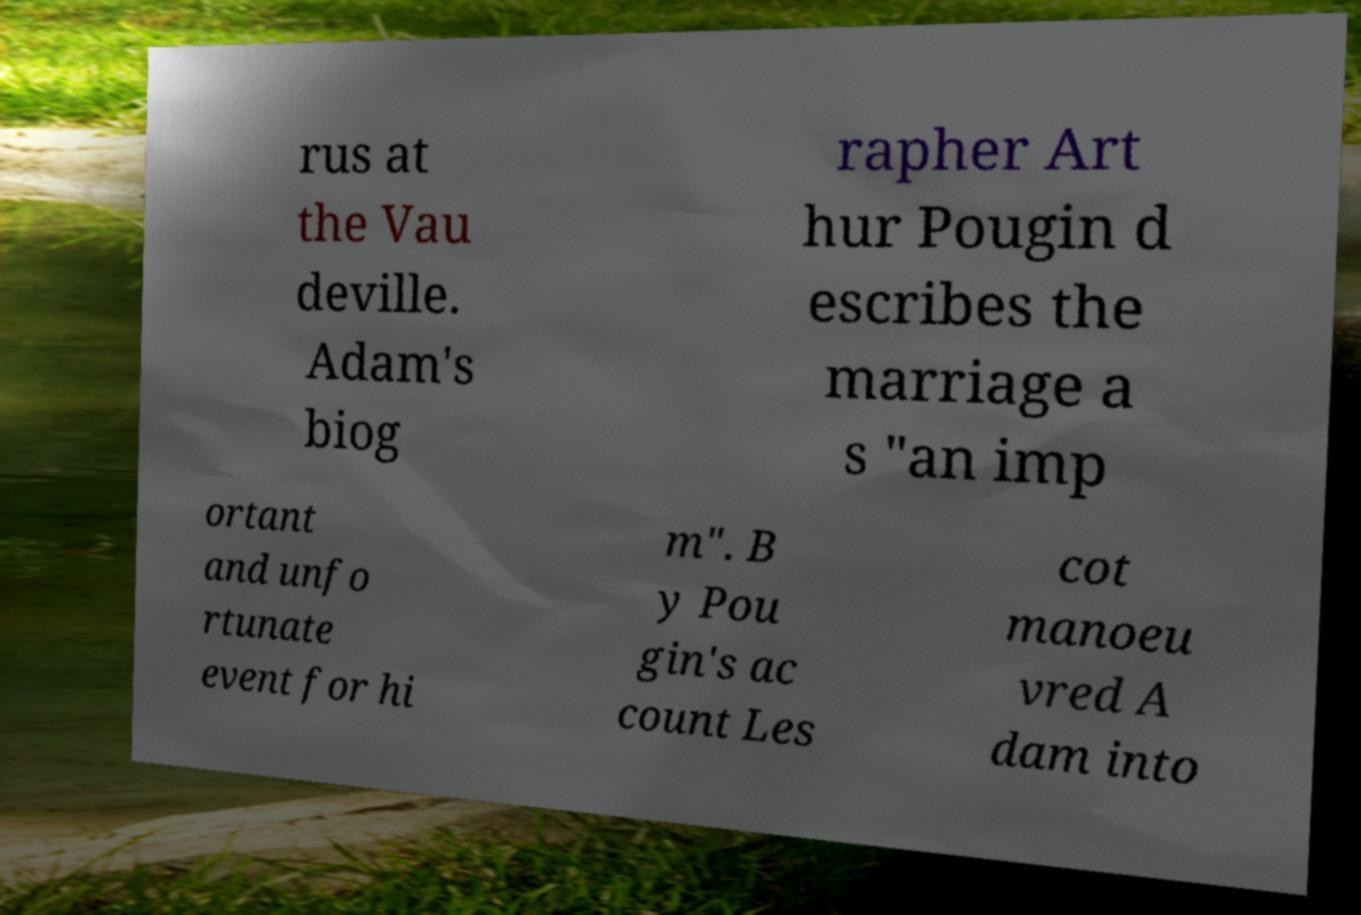Could you extract and type out the text from this image? rus at the Vau deville. Adam's biog rapher Art hur Pougin d escribes the marriage a s "an imp ortant and unfo rtunate event for hi m". B y Pou gin's ac count Les cot manoeu vred A dam into 